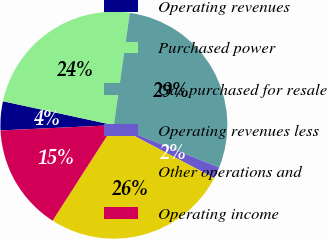<chart> <loc_0><loc_0><loc_500><loc_500><pie_chart><fcel>Operating revenues<fcel>Purchased power<fcel>Gas purchased for resale<fcel>Operating revenues less<fcel>Other operations and<fcel>Operating income<nl><fcel>4.12%<fcel>23.86%<fcel>28.85%<fcel>1.63%<fcel>26.36%<fcel>15.18%<nl></chart> 